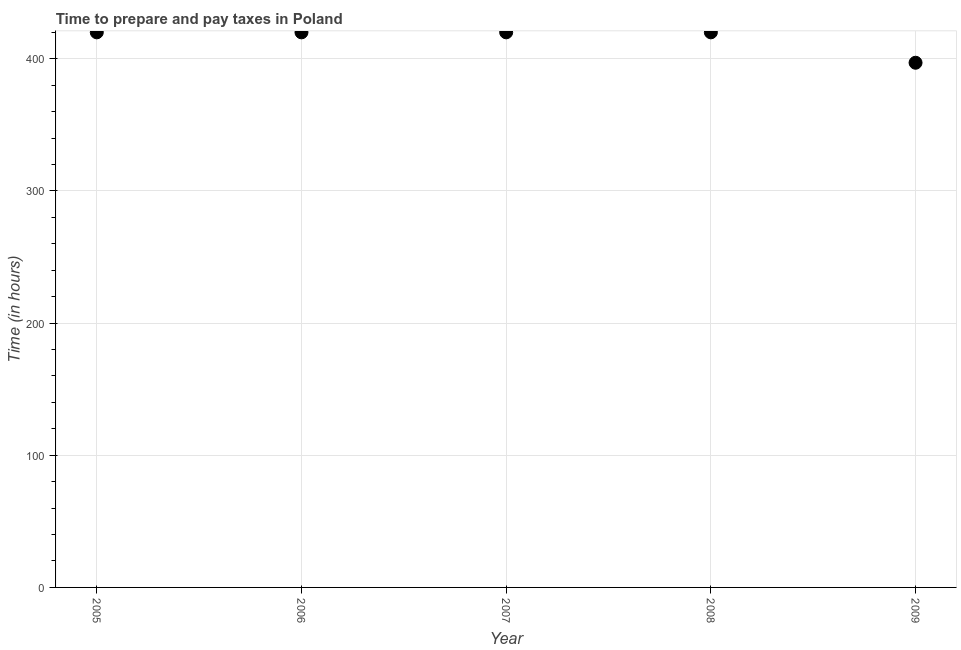What is the time to prepare and pay taxes in 2009?
Ensure brevity in your answer.  397. Across all years, what is the maximum time to prepare and pay taxes?
Make the answer very short. 420. Across all years, what is the minimum time to prepare and pay taxes?
Give a very brief answer. 397. In which year was the time to prepare and pay taxes minimum?
Keep it short and to the point. 2009. What is the sum of the time to prepare and pay taxes?
Make the answer very short. 2077. What is the difference between the time to prepare and pay taxes in 2005 and 2007?
Your answer should be very brief. 0. What is the average time to prepare and pay taxes per year?
Offer a very short reply. 415.4. What is the median time to prepare and pay taxes?
Offer a very short reply. 420. In how many years, is the time to prepare and pay taxes greater than 340 hours?
Your answer should be very brief. 5. What is the ratio of the time to prepare and pay taxes in 2006 to that in 2007?
Your answer should be very brief. 1. What is the difference between the highest and the second highest time to prepare and pay taxes?
Ensure brevity in your answer.  0. What is the difference between the highest and the lowest time to prepare and pay taxes?
Offer a very short reply. 23. In how many years, is the time to prepare and pay taxes greater than the average time to prepare and pay taxes taken over all years?
Make the answer very short. 4. Does the time to prepare and pay taxes monotonically increase over the years?
Offer a very short reply. No. How many dotlines are there?
Your answer should be very brief. 1. What is the difference between two consecutive major ticks on the Y-axis?
Offer a terse response. 100. Does the graph contain any zero values?
Give a very brief answer. No. Does the graph contain grids?
Keep it short and to the point. Yes. What is the title of the graph?
Offer a terse response. Time to prepare and pay taxes in Poland. What is the label or title of the Y-axis?
Offer a very short reply. Time (in hours). What is the Time (in hours) in 2005?
Provide a succinct answer. 420. What is the Time (in hours) in 2006?
Your answer should be very brief. 420. What is the Time (in hours) in 2007?
Offer a terse response. 420. What is the Time (in hours) in 2008?
Keep it short and to the point. 420. What is the Time (in hours) in 2009?
Make the answer very short. 397. What is the difference between the Time (in hours) in 2005 and 2006?
Your answer should be compact. 0. What is the difference between the Time (in hours) in 2005 and 2007?
Make the answer very short. 0. What is the difference between the Time (in hours) in 2005 and 2008?
Provide a succinct answer. 0. What is the difference between the Time (in hours) in 2005 and 2009?
Offer a very short reply. 23. What is the difference between the Time (in hours) in 2006 and 2007?
Offer a terse response. 0. What is the difference between the Time (in hours) in 2006 and 2009?
Offer a terse response. 23. What is the difference between the Time (in hours) in 2007 and 2008?
Keep it short and to the point. 0. What is the difference between the Time (in hours) in 2008 and 2009?
Make the answer very short. 23. What is the ratio of the Time (in hours) in 2005 to that in 2006?
Your answer should be very brief. 1. What is the ratio of the Time (in hours) in 2005 to that in 2007?
Ensure brevity in your answer.  1. What is the ratio of the Time (in hours) in 2005 to that in 2009?
Give a very brief answer. 1.06. What is the ratio of the Time (in hours) in 2006 to that in 2009?
Offer a terse response. 1.06. What is the ratio of the Time (in hours) in 2007 to that in 2008?
Provide a succinct answer. 1. What is the ratio of the Time (in hours) in 2007 to that in 2009?
Provide a succinct answer. 1.06. What is the ratio of the Time (in hours) in 2008 to that in 2009?
Make the answer very short. 1.06. 